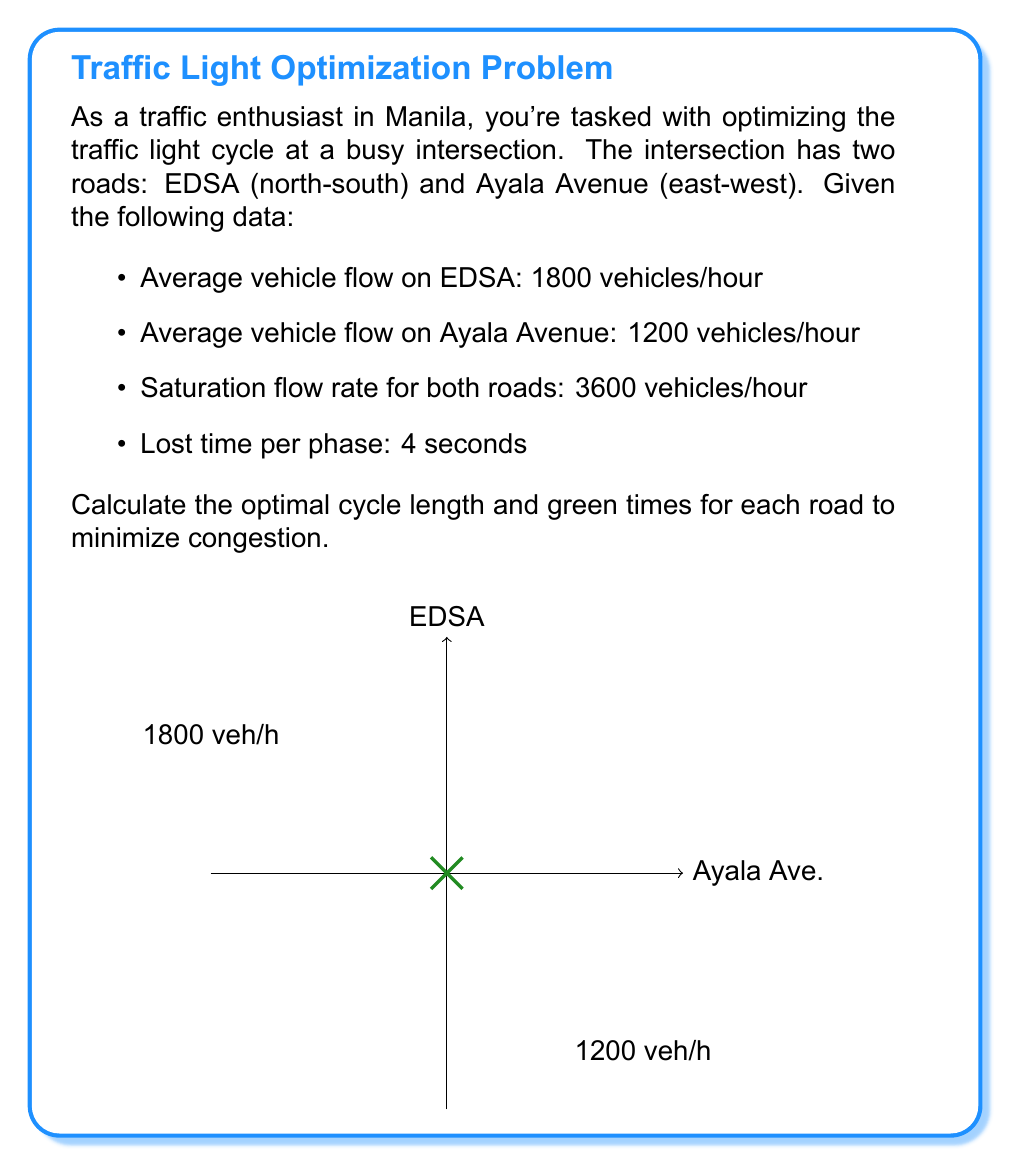Can you answer this question? Let's solve this step-by-step using Webster's method:

1) First, calculate the critical flow ratio for each road:
   EDSA: $y_1 = \frac{1800}{3600} = 0.5$
   Ayala Ave: $y_2 = \frac{1200}{3600} = 0.333$

2) Calculate the sum of critical flow ratios:
   $Y = y_1 + y_2 = 0.5 + 0.333 = 0.833$

3) Calculate the total lost time:
   $L = 2 \times 4 = 8$ seconds (2 phases, 4 seconds each)

4) Use Webster's formula to calculate the optimal cycle length:
   $C_o = \frac{1.5L + 5}{1 - Y} = \frac{1.5(8) + 5}{1 - 0.833} = \frac{17}{0.167} \approx 101.8$ seconds

5) Round to the nearest 5 seconds:
   $C = 100$ seconds

6) Calculate the effective green time:
   $g_e = C - L = 100 - 8 = 92$ seconds

7) Allocate green time proportionally:
   EDSA: $g_1 = \frac{y_1}{Y} \times g_e = \frac{0.5}{0.833} \times 92 \approx 55.2$ seconds
   Ayala Ave: $g_2 = \frac{y_2}{Y} \times g_e = \frac{0.333}{0.833} \times 92 \approx 36.8$ seconds

8) Round to the nearest second:
   EDSA: 55 seconds
   Ayala Ave: 37 seconds
Answer: Cycle length: 100 seconds; EDSA green time: 55 seconds; Ayala Avenue green time: 37 seconds 